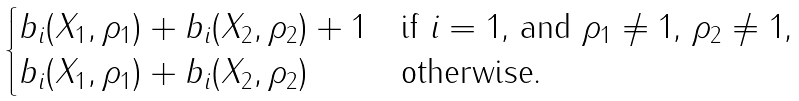Convert formula to latex. <formula><loc_0><loc_0><loc_500><loc_500>\begin{cases} b _ { i } ( X _ { 1 } , \rho _ { 1 } ) + b _ { i } ( X _ { 2 } , \rho _ { 2 } ) + 1 & \text {if $i=1$, and $\rho_{1}\ne 1$, $\rho_{2}\ne 1$,} \\ b _ { i } ( X _ { 1 } , \rho _ { 1 } ) + b _ { i } ( X _ { 2 } , \rho _ { 2 } ) & \text {otherwise.} \end{cases}</formula> 